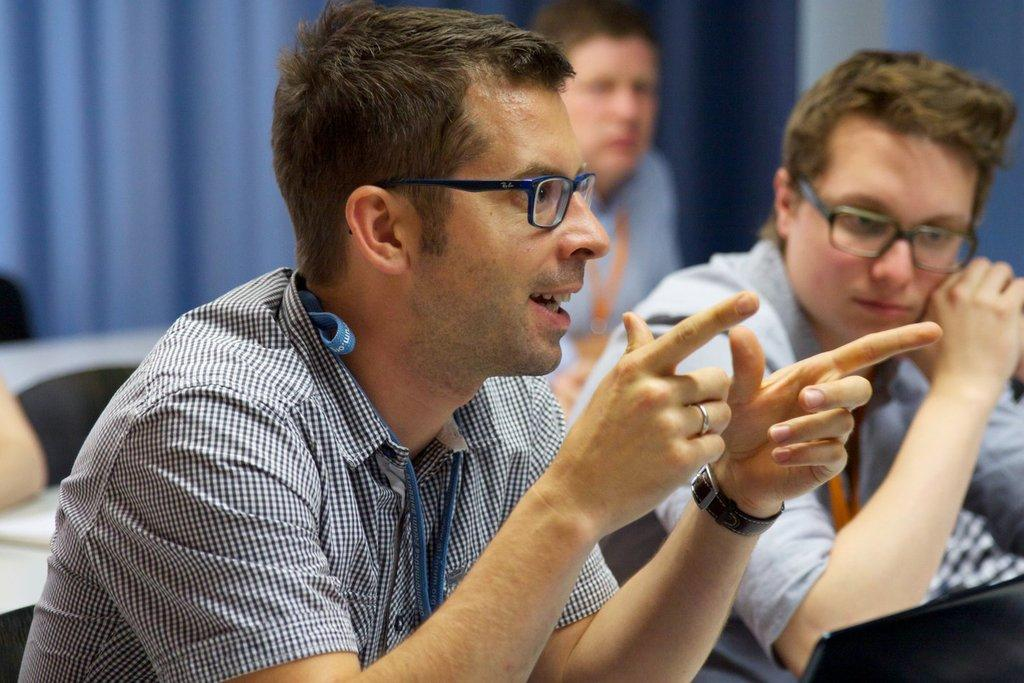How many people are in the image? There are three men in the image. What are the positions of the men in the image? Two of the men are sitting in the front, and one person is standing. What can be observed about the two men in the front? Both of them are wearing spectacles and shirts. What accessory is the person wearing in the image? The person is wearing a watch. What type of toy is the person holding in the image? There is no toy present in the image. Can you describe the eye color of the person in the image? The eye color of the person cannot be determined from the image. 